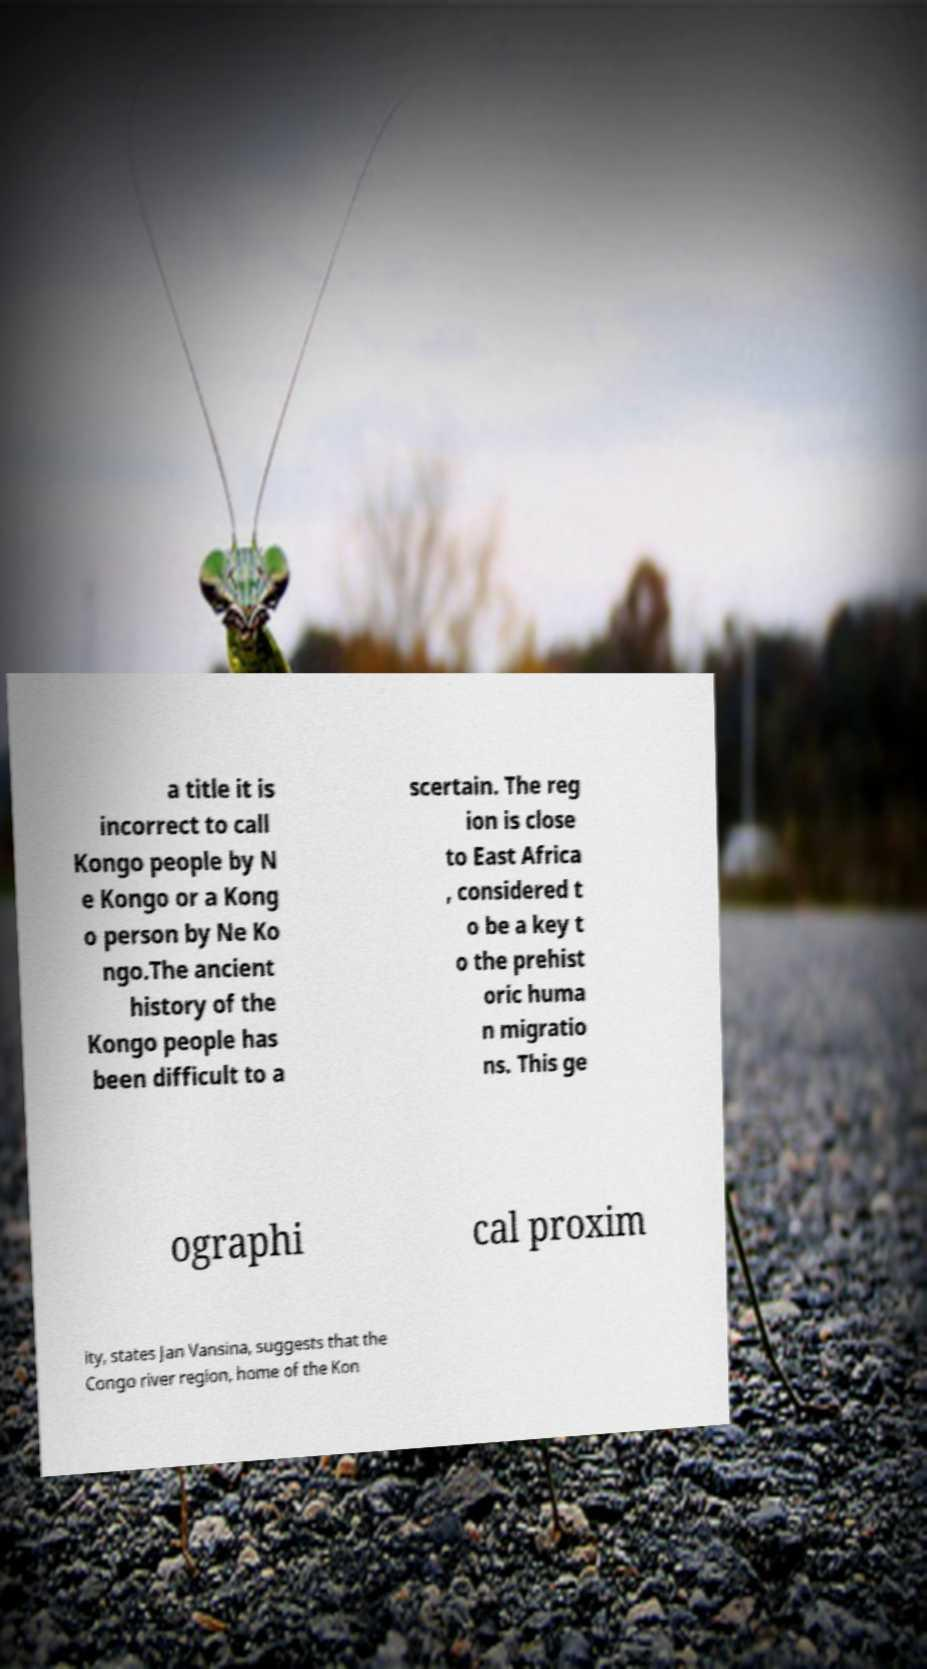For documentation purposes, I need the text within this image transcribed. Could you provide that? a title it is incorrect to call Kongo people by N e Kongo or a Kong o person by Ne Ko ngo.The ancient history of the Kongo people has been difficult to a scertain. The reg ion is close to East Africa , considered t o be a key t o the prehist oric huma n migratio ns. This ge ographi cal proxim ity, states Jan Vansina, suggests that the Congo river region, home of the Kon 